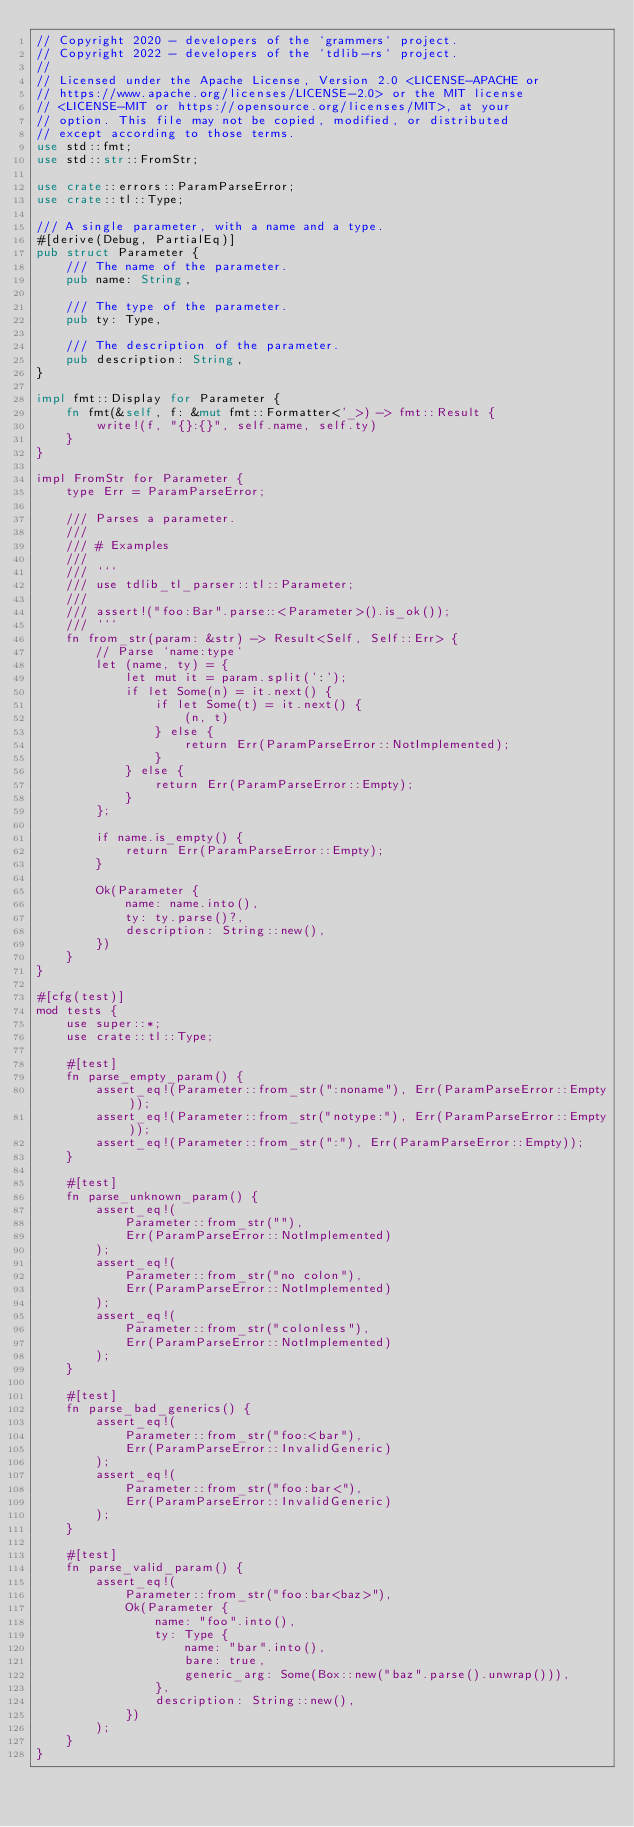Convert code to text. <code><loc_0><loc_0><loc_500><loc_500><_Rust_>// Copyright 2020 - developers of the `grammers` project.
// Copyright 2022 - developers of the `tdlib-rs` project.
//
// Licensed under the Apache License, Version 2.0 <LICENSE-APACHE or
// https://www.apache.org/licenses/LICENSE-2.0> or the MIT license
// <LICENSE-MIT or https://opensource.org/licenses/MIT>, at your
// option. This file may not be copied, modified, or distributed
// except according to those terms.
use std::fmt;
use std::str::FromStr;

use crate::errors::ParamParseError;
use crate::tl::Type;

/// A single parameter, with a name and a type.
#[derive(Debug, PartialEq)]
pub struct Parameter {
    /// The name of the parameter.
    pub name: String,

    /// The type of the parameter.
    pub ty: Type,

    /// The description of the parameter.
    pub description: String,
}

impl fmt::Display for Parameter {
    fn fmt(&self, f: &mut fmt::Formatter<'_>) -> fmt::Result {
        write!(f, "{}:{}", self.name, self.ty)
    }
}

impl FromStr for Parameter {
    type Err = ParamParseError;

    /// Parses a parameter.
    ///
    /// # Examples
    ///
    /// ```
    /// use tdlib_tl_parser::tl::Parameter;
    ///
    /// assert!("foo:Bar".parse::<Parameter>().is_ok());
    /// ```
    fn from_str(param: &str) -> Result<Self, Self::Err> {
        // Parse `name:type`
        let (name, ty) = {
            let mut it = param.split(':');
            if let Some(n) = it.next() {
                if let Some(t) = it.next() {
                    (n, t)
                } else {
                    return Err(ParamParseError::NotImplemented);
                }
            } else {
                return Err(ParamParseError::Empty);
            }
        };

        if name.is_empty() {
            return Err(ParamParseError::Empty);
        }

        Ok(Parameter {
            name: name.into(),
            ty: ty.parse()?,
            description: String::new(),
        })
    }
}

#[cfg(test)]
mod tests {
    use super::*;
    use crate::tl::Type;

    #[test]
    fn parse_empty_param() {
        assert_eq!(Parameter::from_str(":noname"), Err(ParamParseError::Empty));
        assert_eq!(Parameter::from_str("notype:"), Err(ParamParseError::Empty));
        assert_eq!(Parameter::from_str(":"), Err(ParamParseError::Empty));
    }

    #[test]
    fn parse_unknown_param() {
        assert_eq!(
            Parameter::from_str(""),
            Err(ParamParseError::NotImplemented)
        );
        assert_eq!(
            Parameter::from_str("no colon"),
            Err(ParamParseError::NotImplemented)
        );
        assert_eq!(
            Parameter::from_str("colonless"),
            Err(ParamParseError::NotImplemented)
        );
    }

    #[test]
    fn parse_bad_generics() {
        assert_eq!(
            Parameter::from_str("foo:<bar"),
            Err(ParamParseError::InvalidGeneric)
        );
        assert_eq!(
            Parameter::from_str("foo:bar<"),
            Err(ParamParseError::InvalidGeneric)
        );
    }

    #[test]
    fn parse_valid_param() {
        assert_eq!(
            Parameter::from_str("foo:bar<baz>"),
            Ok(Parameter {
                name: "foo".into(),
                ty: Type {
                    name: "bar".into(),
                    bare: true,
                    generic_arg: Some(Box::new("baz".parse().unwrap())),
                },
                description: String::new(),
            })
        );
    }
}
</code> 